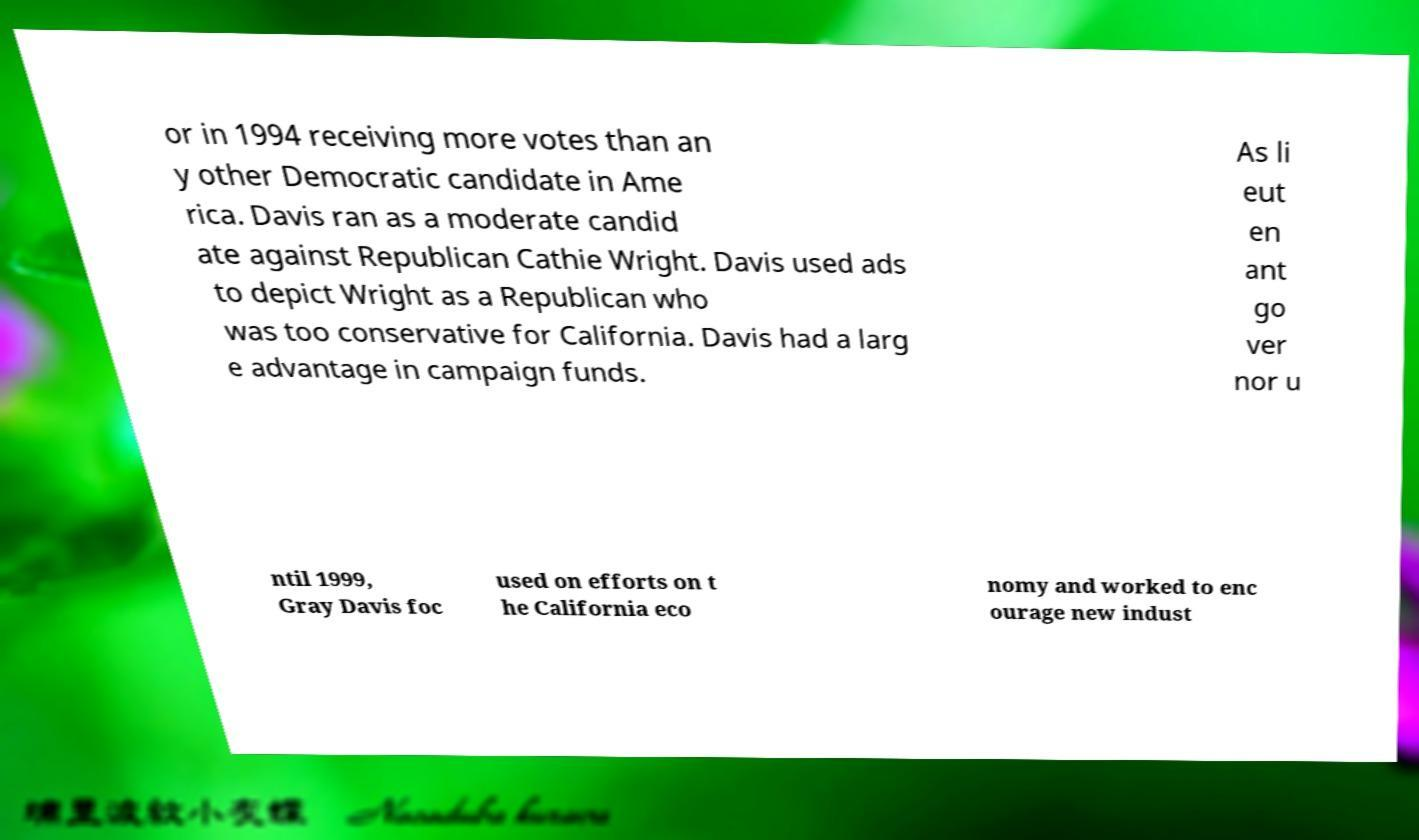Please identify and transcribe the text found in this image. or in 1994 receiving more votes than an y other Democratic candidate in Ame rica. Davis ran as a moderate candid ate against Republican Cathie Wright. Davis used ads to depict Wright as a Republican who was too conservative for California. Davis had a larg e advantage in campaign funds. As li eut en ant go ver nor u ntil 1999, Gray Davis foc used on efforts on t he California eco nomy and worked to enc ourage new indust 